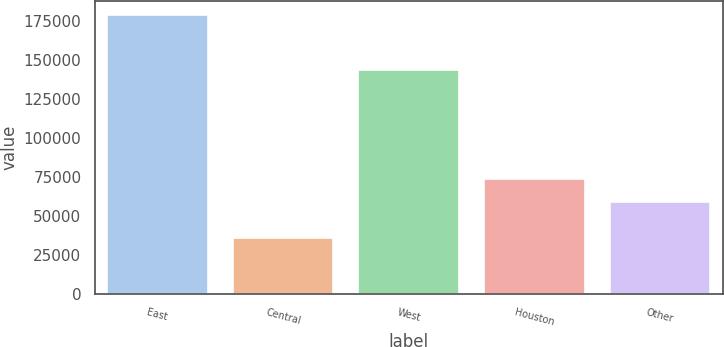<chart> <loc_0><loc_0><loc_500><loc_500><bar_chart><fcel>East<fcel>Central<fcel>West<fcel>Houston<fcel>Other<nl><fcel>179175<fcel>36158<fcel>143868<fcel>73795.7<fcel>59494<nl></chart> 